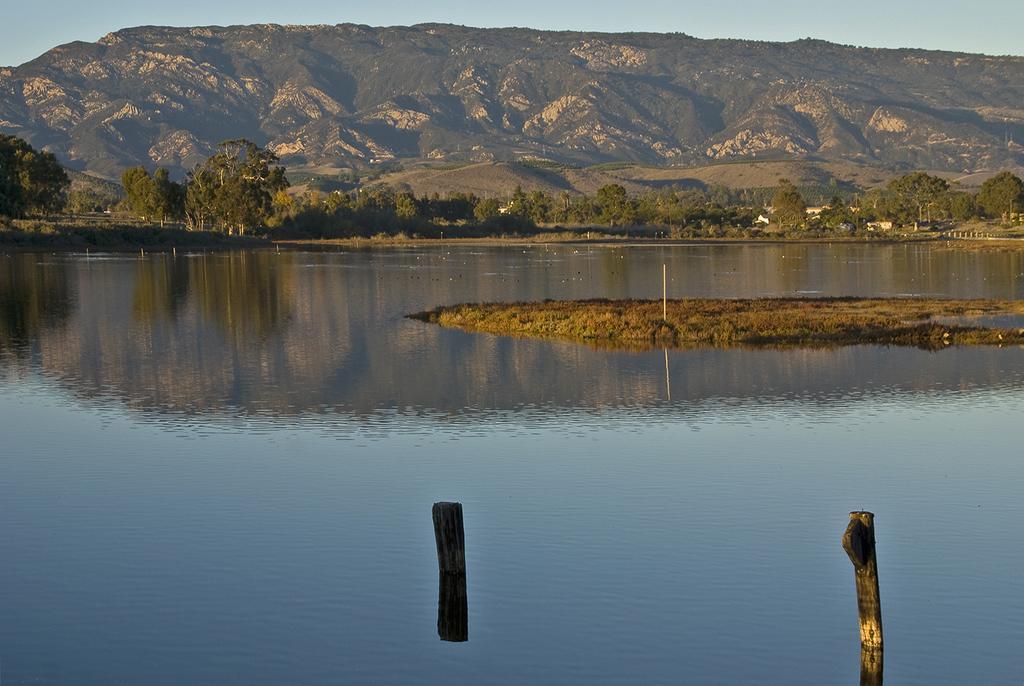In one or two sentences, can you explain what this image depicts? In the picture I can see the water. In the background I can see mountains, trees, poles, the sky and some other objects. 